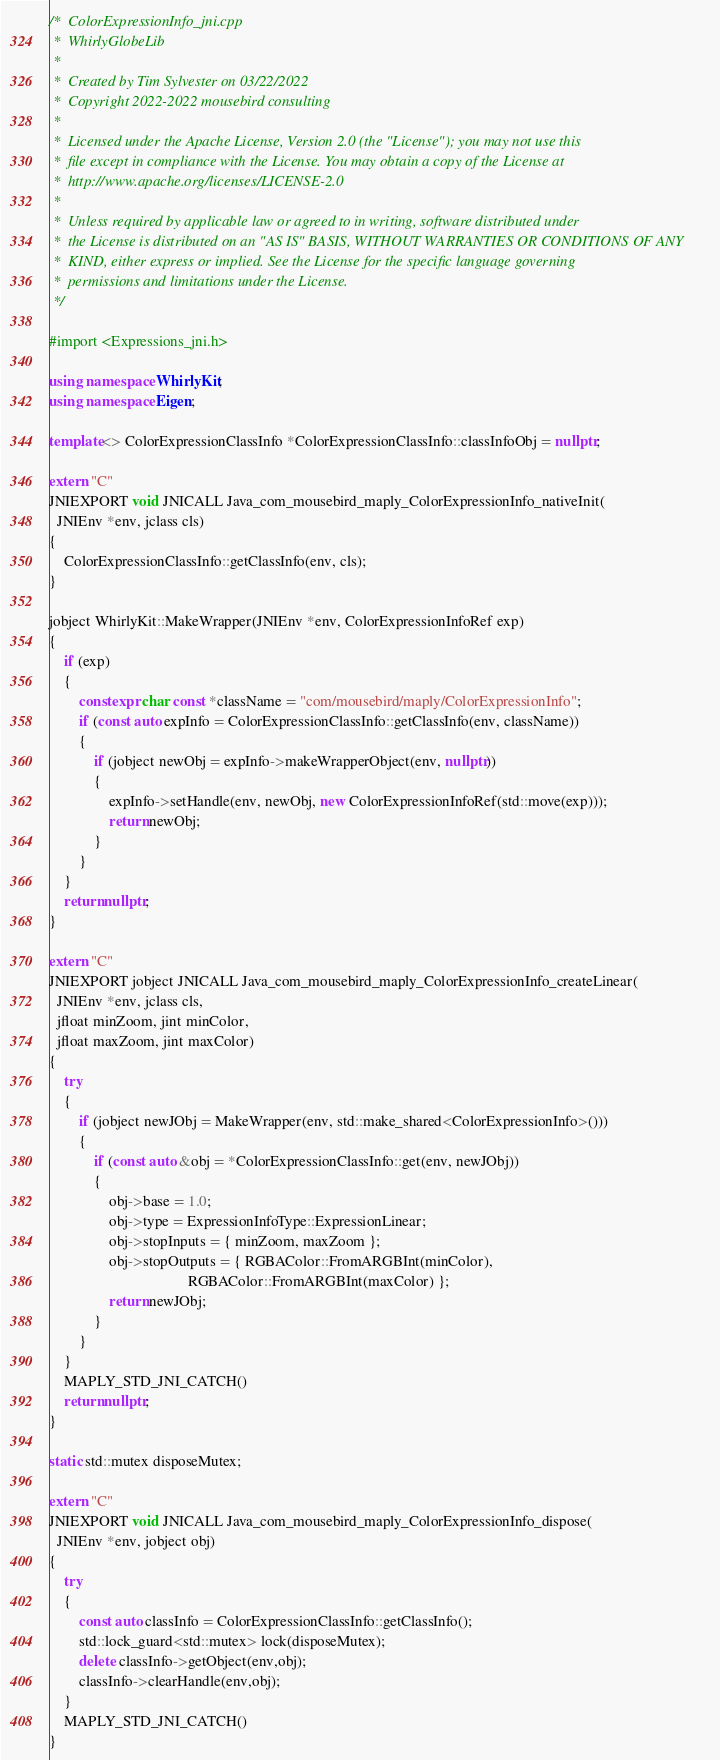<code> <loc_0><loc_0><loc_500><loc_500><_C++_>/*  ColorExpressionInfo_jni.cpp
 *  WhirlyGlobeLib
 *
 *  Created by Tim Sylvester on 03/22/2022
 *  Copyright 2022-2022 mousebird consulting
 *
 *  Licensed under the Apache License, Version 2.0 (the "License"); you may not use this
 *  file except in compliance with the License. You may obtain a copy of the License at
 *  http://www.apache.org/licenses/LICENSE-2.0
 *
 *  Unless required by applicable law or agreed to in writing, software distributed under
 *  the License is distributed on an "AS IS" BASIS, WITHOUT WARRANTIES OR CONDITIONS OF ANY
 *  KIND, either express or implied. See the License for the specific language governing
 *  permissions and limitations under the License.
 */

#import <Expressions_jni.h>

using namespace WhirlyKit;
using namespace Eigen;

template<> ColorExpressionClassInfo *ColorExpressionClassInfo::classInfoObj = nullptr;

extern "C"
JNIEXPORT void JNICALL Java_com_mousebird_maply_ColorExpressionInfo_nativeInit(
  JNIEnv *env, jclass cls)
{
    ColorExpressionClassInfo::getClassInfo(env, cls);
}

jobject WhirlyKit::MakeWrapper(JNIEnv *env, ColorExpressionInfoRef exp)
{
    if (exp)
    {
        constexpr char const *className = "com/mousebird/maply/ColorExpressionInfo";
        if (const auto expInfo = ColorExpressionClassInfo::getClassInfo(env, className))
        {
            if (jobject newObj = expInfo->makeWrapperObject(env, nullptr))
            {
                expInfo->setHandle(env, newObj, new ColorExpressionInfoRef(std::move(exp)));
                return newObj;
            }
        }
    }
    return nullptr;
}

extern "C"
JNIEXPORT jobject JNICALL Java_com_mousebird_maply_ColorExpressionInfo_createLinear(
  JNIEnv *env, jclass cls,
  jfloat minZoom, jint minColor,
  jfloat maxZoom, jint maxColor)
{
    try
    {
        if (jobject newJObj = MakeWrapper(env, std::make_shared<ColorExpressionInfo>()))
        {
            if (const auto &obj = *ColorExpressionClassInfo::get(env, newJObj))
            {
                obj->base = 1.0;
                obj->type = ExpressionInfoType::ExpressionLinear;
                obj->stopInputs = { minZoom, maxZoom };
                obj->stopOutputs = { RGBAColor::FromARGBInt(minColor),
                                     RGBAColor::FromARGBInt(maxColor) };
                return newJObj;
            }
        }
    }
    MAPLY_STD_JNI_CATCH()
    return nullptr;
}

static std::mutex disposeMutex;

extern "C"
JNIEXPORT void JNICALL Java_com_mousebird_maply_ColorExpressionInfo_dispose(
  JNIEnv *env, jobject obj)
{
    try
    {
        const auto classInfo = ColorExpressionClassInfo::getClassInfo();
        std::lock_guard<std::mutex> lock(disposeMutex);
        delete classInfo->getObject(env,obj);
        classInfo->clearHandle(env,obj);
    }
    MAPLY_STD_JNI_CATCH()
}

</code> 